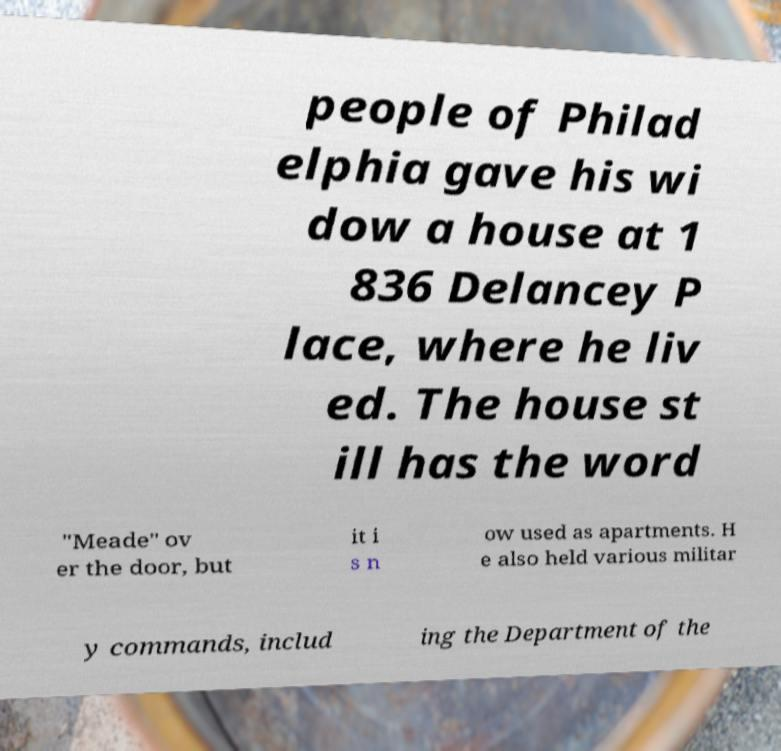For documentation purposes, I need the text within this image transcribed. Could you provide that? people of Philad elphia gave his wi dow a house at 1 836 Delancey P lace, where he liv ed. The house st ill has the word "Meade" ov er the door, but it i s n ow used as apartments. H e also held various militar y commands, includ ing the Department of the 